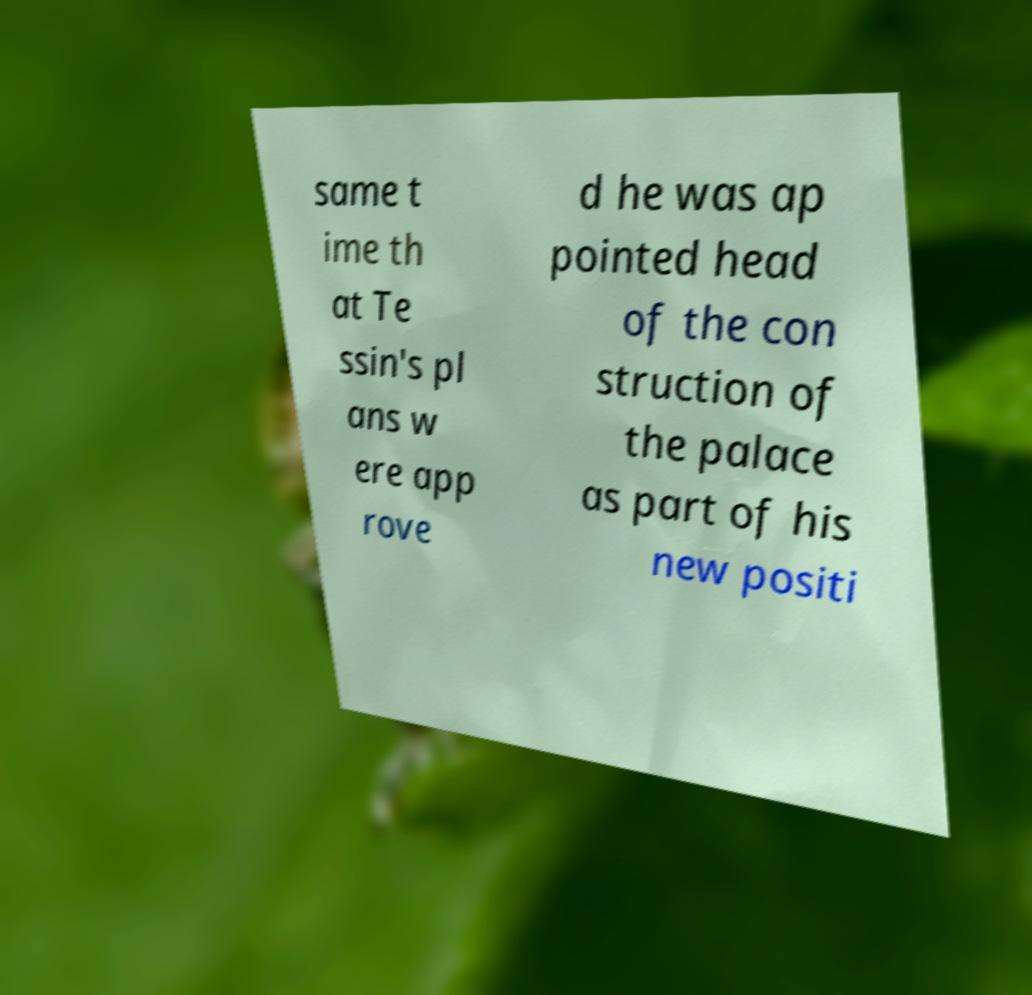Please read and relay the text visible in this image. What does it say? same t ime th at Te ssin's pl ans w ere app rove d he was ap pointed head of the con struction of the palace as part of his new positi 